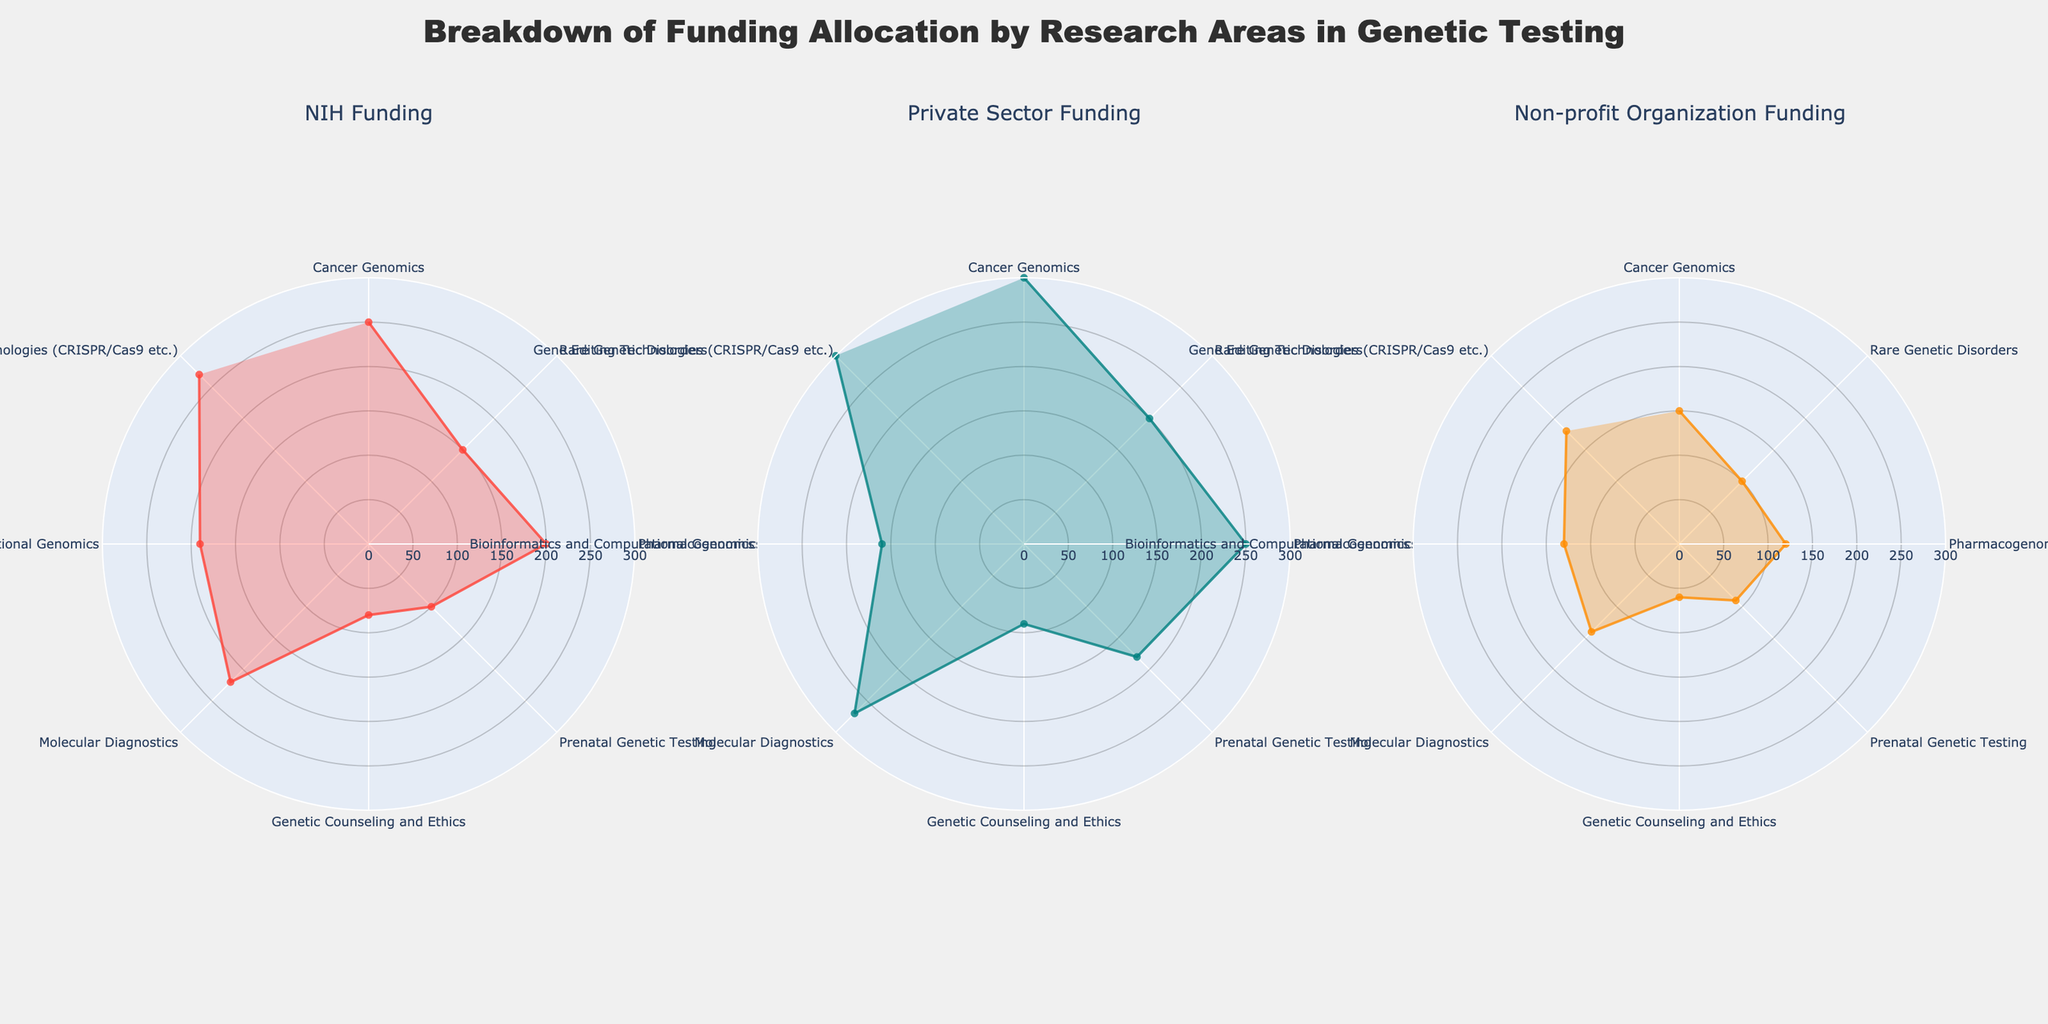What is the research area title of the largest NIH funding category? Visual inspection of the NIH Funding subplot shows that Gene Editing Technologies (CRISPR/Cas9 etc.) has the largest radial value.
Answer: Gene Editing Technologies (CRISPR/Cas9 etc.) What funding amount is provided by private sectors for Pharmacogenomics? By observing the Private Sector Funding subplot, the radial value corresponding to Pharmacogenomics indicates the funding amount provided by private sectors.
Answer: 250 million USD Which funding source provides the least amount for Genetic Counseling and Ethics? In each subplot, compare the radial values for Genetic Counseling and Ethics. Both NIH Funding and Private Sector Funding are higher than Non-profit Organization Funding, which is the smallest.
Answer: Non-profit Organization Funding How much more NIH funding does Cancer Genomics receive compared to Prenatal Genetic Testing? From the radial values in the NIH Funding subplot, Cancer Genomics receives 250 million USD and Prenatal Genetic Testing receives 100 million USD. The difference is 250 - 100.
Answer: 150 million USD What is the average amount of funding provided by non-profit organizations for all research areas? Sum the radial values from the Non-profit Organization Funding subplot and divide by the number of categories. Total is (150 + 100 + 120 + 90 + 60 + 140 + 130 + 180) = 970. There are 8 research areas. 970 / 8.
Answer: 121.25 million USD Which research area has the smallest private sector funding allocation, and what is the amount? Visual inspection of the Private Sector Funding subplot shows that Genetic Counseling and Ethics has the smallest radial value.
Answer: Genetic Counseling and Ethics, 90 million USD What is the sum of non-profit organization funding for Cancer Genomics and Bioinformatics and Computational Genomics? Add the radial values from the Non-profit Organization Funding subplot for Cancer Genomics (150 million) and Bioinformatics and Computational Genomics (130 million). 150 + 130.
Answer: 280 million USD Which research area receives the most balanced funding among all three sources (NIH Funding, Private Sector Funding, Non-profit Organization Funding)? By comparing relative uniformity across three subplots, Cancer Genomics has similar radial extents in all funding categories.
Answer: Cancer Genomics Compare the NIH funding difference between Molecular Diagnostics and Bioinformatics and Computational Genomics. The radial value in the NIH Funding subplot for Molecular Diagnostics is 220 million USD and for Bioinformatics and Computational Genomics is 190 million USD. The difference is 220 - 190.
Answer: 30 million USD How much total funding does Gene Editing Technologies receive from all sources? Sum the radial values from each subplot for Gene Editing Technologies. NIH Funding is 270, Private Sector Funding is 300, Non-profit Organization Funding is 180. Total funding = 270 + 300 + 180.
Answer: 750 million USD 